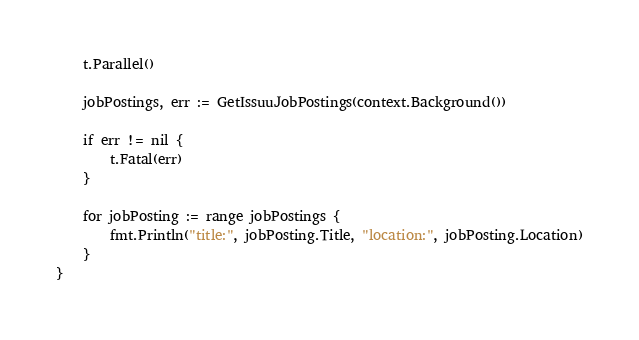<code> <loc_0><loc_0><loc_500><loc_500><_Go_>	t.Parallel()

	jobPostings, err := GetIssuuJobPostings(context.Background())

	if err != nil {
		t.Fatal(err)
	}

	for jobPosting := range jobPostings {
		fmt.Println("title:", jobPosting.Title, "location:", jobPosting.Location)
	}
}
</code> 